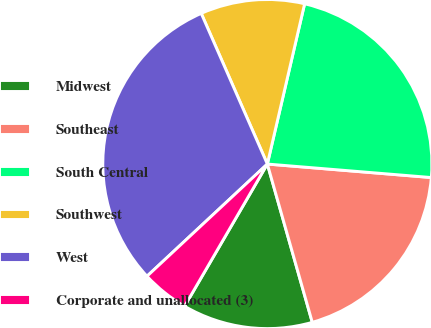Convert chart to OTSL. <chart><loc_0><loc_0><loc_500><loc_500><pie_chart><fcel>Midwest<fcel>Southeast<fcel>South Central<fcel>Southwest<fcel>West<fcel>Corporate and unallocated (3)<nl><fcel>12.79%<fcel>19.29%<fcel>22.67%<fcel>10.22%<fcel>30.36%<fcel>4.67%<nl></chart> 